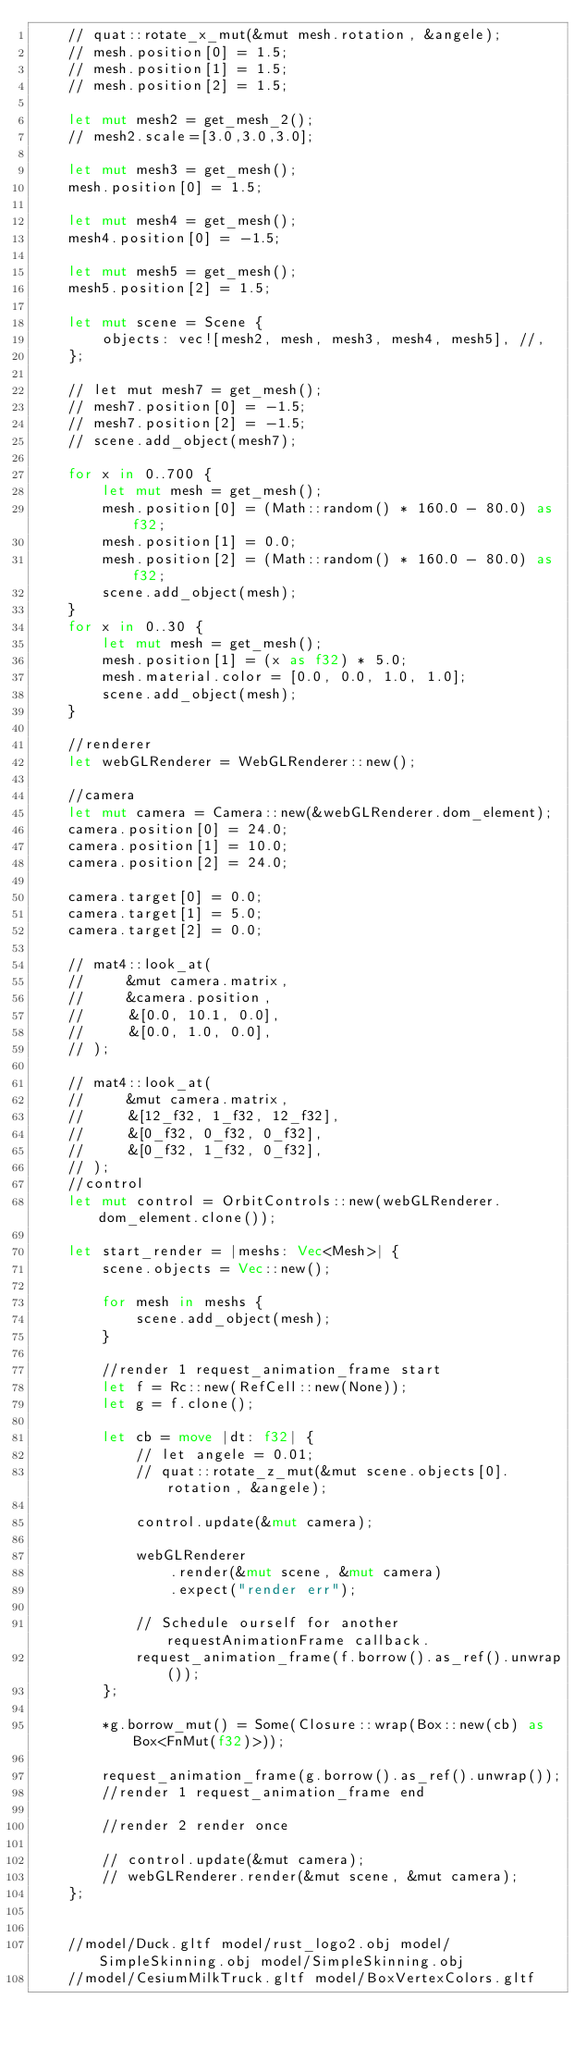<code> <loc_0><loc_0><loc_500><loc_500><_Rust_>    // quat::rotate_x_mut(&mut mesh.rotation, &angele);
    // mesh.position[0] = 1.5;
    // mesh.position[1] = 1.5;
    // mesh.position[2] = 1.5;

    let mut mesh2 = get_mesh_2();
    // mesh2.scale=[3.0,3.0,3.0];

    let mut mesh3 = get_mesh();
    mesh.position[0] = 1.5;

    let mut mesh4 = get_mesh();
    mesh4.position[0] = -1.5;

    let mut mesh5 = get_mesh();
    mesh5.position[2] = 1.5;

    let mut scene = Scene {
        objects: vec![mesh2, mesh, mesh3, mesh4, mesh5], //,
    };

    // let mut mesh7 = get_mesh();
    // mesh7.position[0] = -1.5;
    // mesh7.position[2] = -1.5;
    // scene.add_object(mesh7);

    for x in 0..700 {
        let mut mesh = get_mesh();
        mesh.position[0] = (Math::random() * 160.0 - 80.0) as f32;
        mesh.position[1] = 0.0;
        mesh.position[2] = (Math::random() * 160.0 - 80.0) as f32;
        scene.add_object(mesh);
    }
    for x in 0..30 {
        let mut mesh = get_mesh();
        mesh.position[1] = (x as f32) * 5.0;
        mesh.material.color = [0.0, 0.0, 1.0, 1.0];
        scene.add_object(mesh);
    }

    //renderer
    let webGLRenderer = WebGLRenderer::new();

    //camera
    let mut camera = Camera::new(&webGLRenderer.dom_element);
    camera.position[0] = 24.0;
    camera.position[1] = 10.0;
    camera.position[2] = 24.0;

    camera.target[0] = 0.0;
    camera.target[1] = 5.0;
    camera.target[2] = 0.0;

    // mat4::look_at(
    //     &mut camera.matrix,
    //     &camera.position,
    //     &[0.0, 10.1, 0.0],
    //     &[0.0, 1.0, 0.0],
    // );

    // mat4::look_at(
    //     &mut camera.matrix,
    //     &[12_f32, 1_f32, 12_f32],
    //     &[0_f32, 0_f32, 0_f32],
    //     &[0_f32, 1_f32, 0_f32],
    // );
    //control
    let mut control = OrbitControls::new(webGLRenderer.dom_element.clone());

    let start_render = |meshs: Vec<Mesh>| {
        scene.objects = Vec::new();

        for mesh in meshs {
            scene.add_object(mesh);
        }

        //render 1 request_animation_frame start
        let f = Rc::new(RefCell::new(None));
        let g = f.clone();

        let cb = move |dt: f32| {
            // let angele = 0.01;
            // quat::rotate_z_mut(&mut scene.objects[0].rotation, &angele);

            control.update(&mut camera);

            webGLRenderer
                .render(&mut scene, &mut camera)
                .expect("render err");

            // Schedule ourself for another requestAnimationFrame callback.
            request_animation_frame(f.borrow().as_ref().unwrap());
        };

        *g.borrow_mut() = Some(Closure::wrap(Box::new(cb) as Box<FnMut(f32)>));

        request_animation_frame(g.borrow().as_ref().unwrap());
        //render 1 request_animation_frame end

        //render 2 render once

        // control.update(&mut camera);
        // webGLRenderer.render(&mut scene, &mut camera);
    };


    //model/Duck.gltf model/rust_logo2.obj model/SimpleSkinning.obj model/SimpleSkinning.obj
    //model/CesiumMilkTruck.gltf model/BoxVertexColors.gltf</code> 